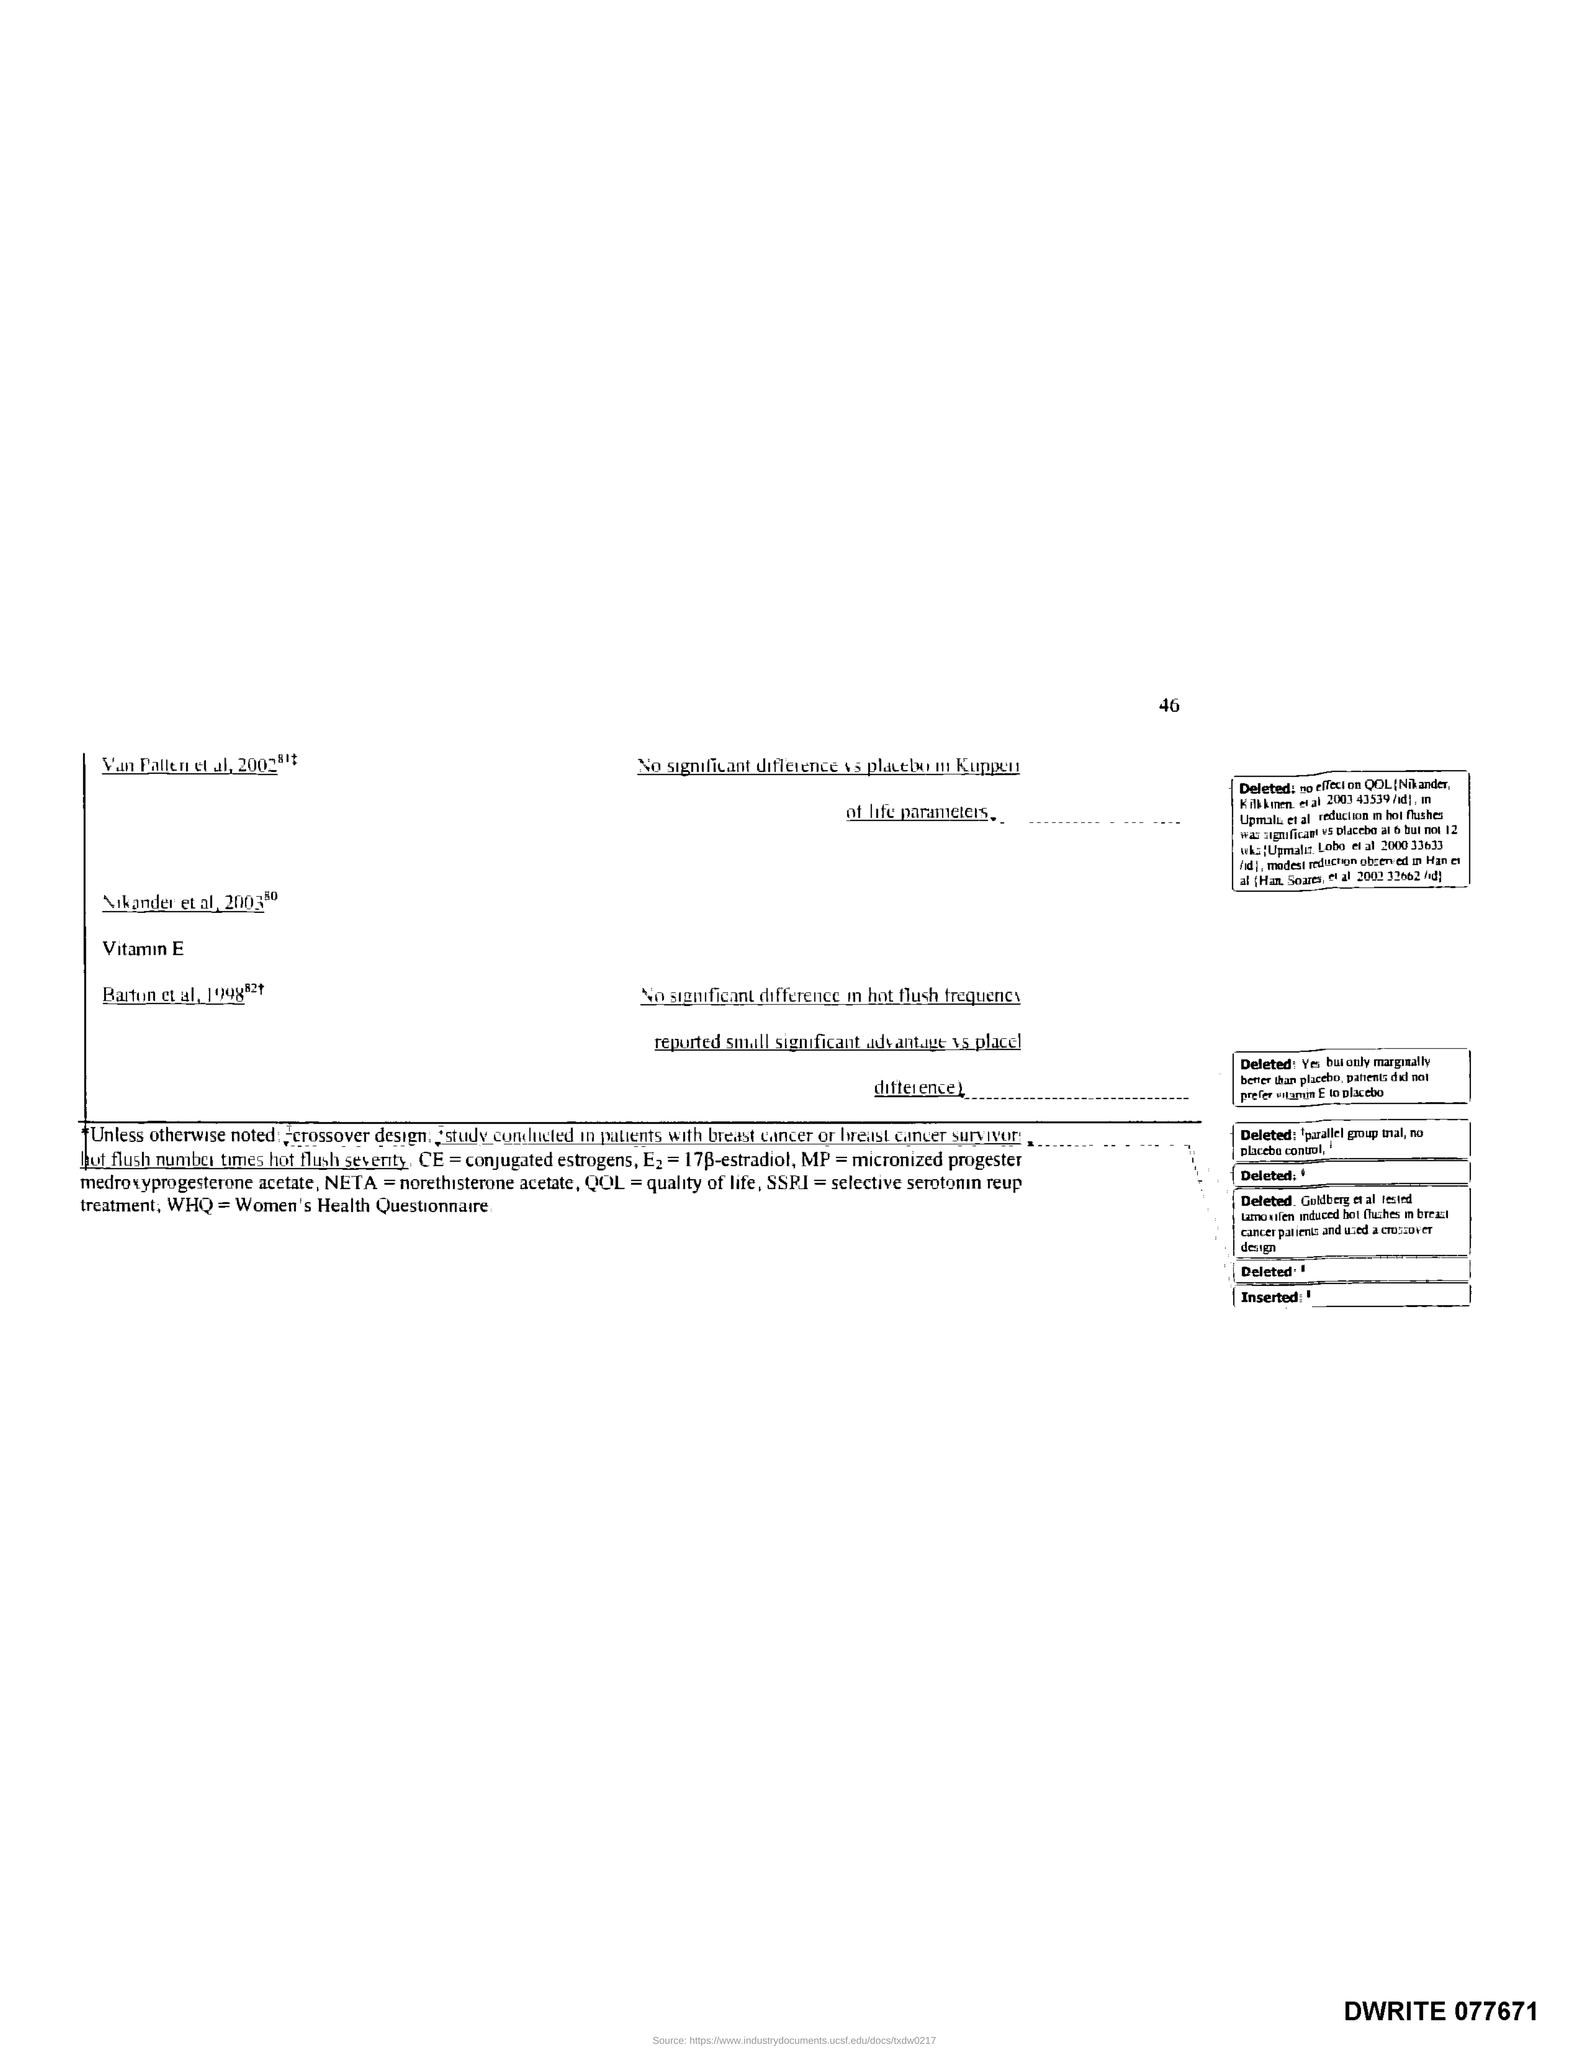What is the Page Number?
Provide a short and direct response. 46. 